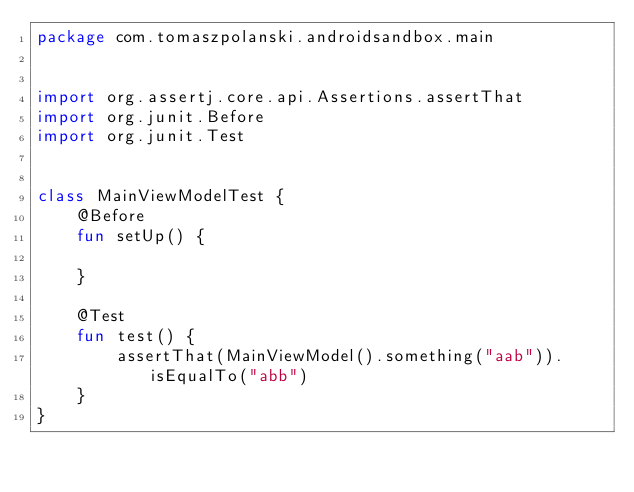<code> <loc_0><loc_0><loc_500><loc_500><_Kotlin_>package com.tomaszpolanski.androidsandbox.main


import org.assertj.core.api.Assertions.assertThat
import org.junit.Before
import org.junit.Test


class MainViewModelTest {
    @Before
    fun setUp() {

    }

    @Test
    fun test() {
        assertThat(MainViewModel().something("aab")).isEqualTo("abb")
    }
}</code> 